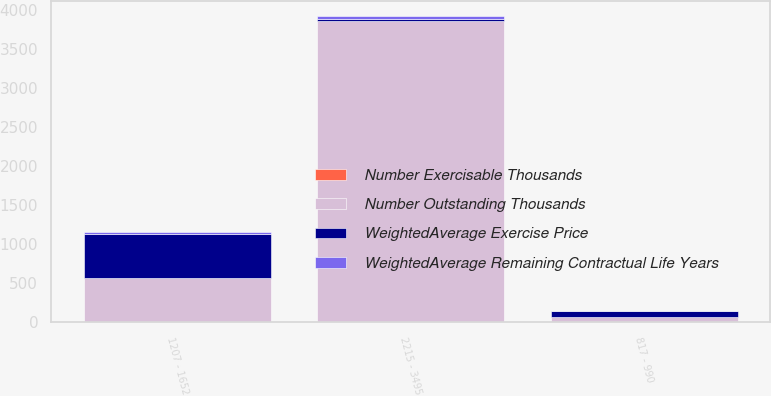<chart> <loc_0><loc_0><loc_500><loc_500><stacked_bar_chart><ecel><fcel>817 - 990<fcel>1207 - 1652<fcel>2215 - 3495<nl><fcel>WeightedAverage Exercise Price<fcel>72<fcel>569<fcel>30.02<nl><fcel>Number Exercisable Thousands<fcel>0<fcel>0.3<fcel>5.5<nl><fcel>WeightedAverage Remaining Contractual Life Years<fcel>9.02<fcel>14.12<fcel>30.02<nl><fcel>Number Outstanding Thousands<fcel>72<fcel>569<fcel>3853<nl></chart> 